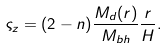Convert formula to latex. <formula><loc_0><loc_0><loc_500><loc_500>\varsigma _ { z } = ( 2 - n ) \frac { M _ { d } ( r ) } { M _ { b h } } \frac { r } { H } .</formula> 